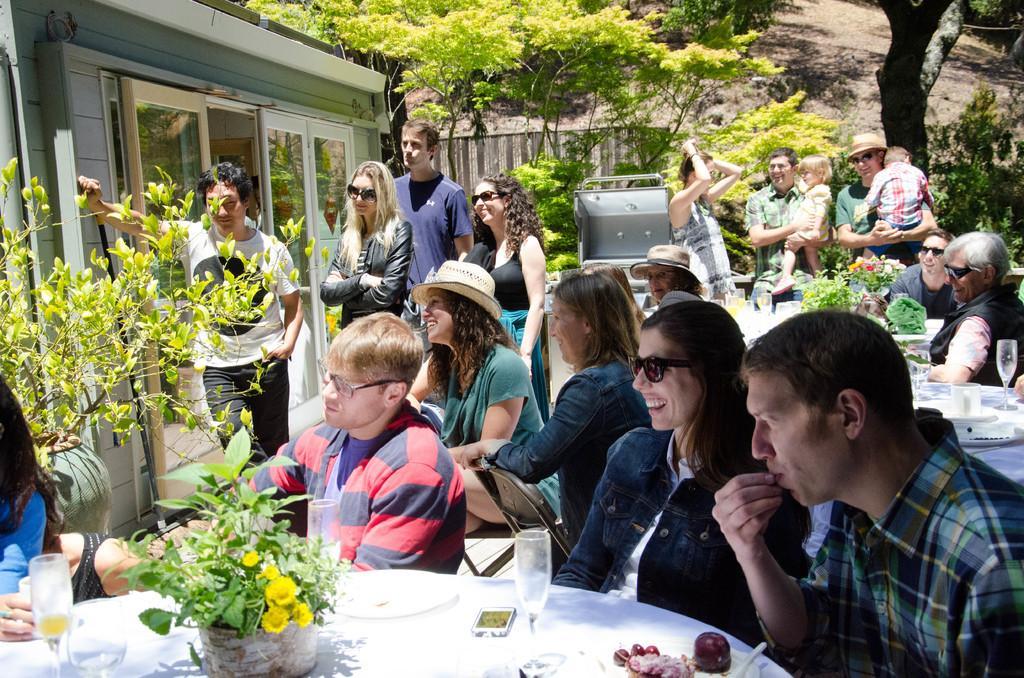Can you describe this image briefly? In this picture there are group of people sitting on the chair. There are four people standing to the left. There is a flower pot, plant, phone, glass, bowl on the table. There is a house and few trees at the background. There is a man holding a baby in his hand. There is also another man holding a baby in his hand. 